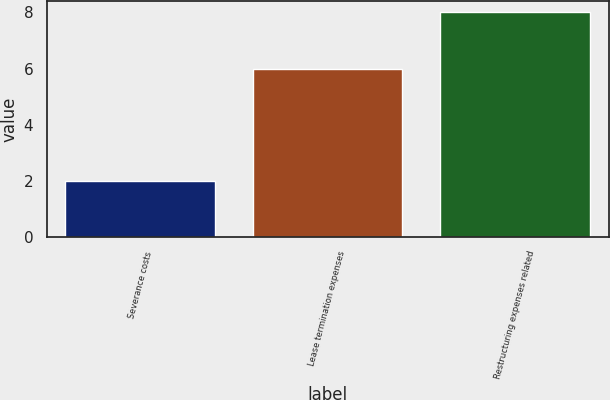<chart> <loc_0><loc_0><loc_500><loc_500><bar_chart><fcel>Severance costs<fcel>Lease termination expenses<fcel>Restructuring expenses related<nl><fcel>2<fcel>6<fcel>8<nl></chart> 